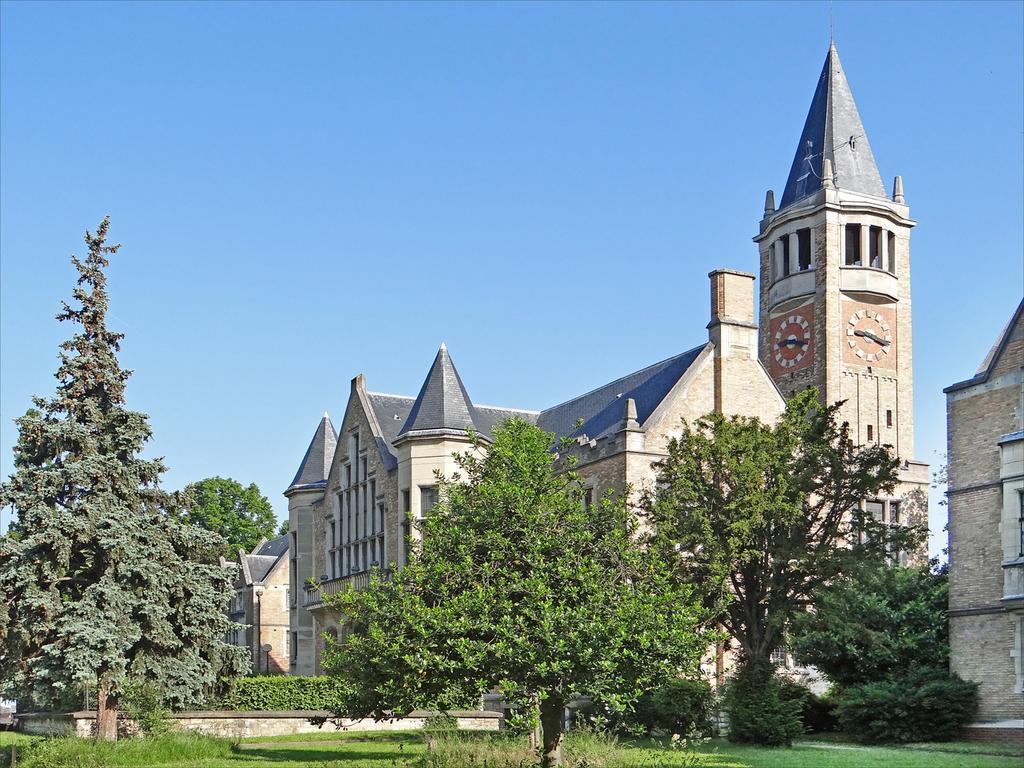Can you describe this image briefly? In this image there are some buildings and a clock tower, in the foreground there are some trees. At the bottom there is grass, on the top of the image there is sky. 